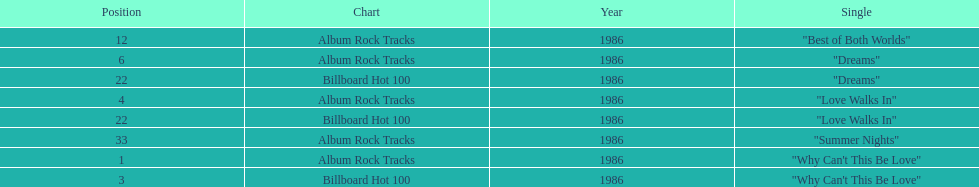Which is the most popular single on the album? Why Can't This Be Love. 